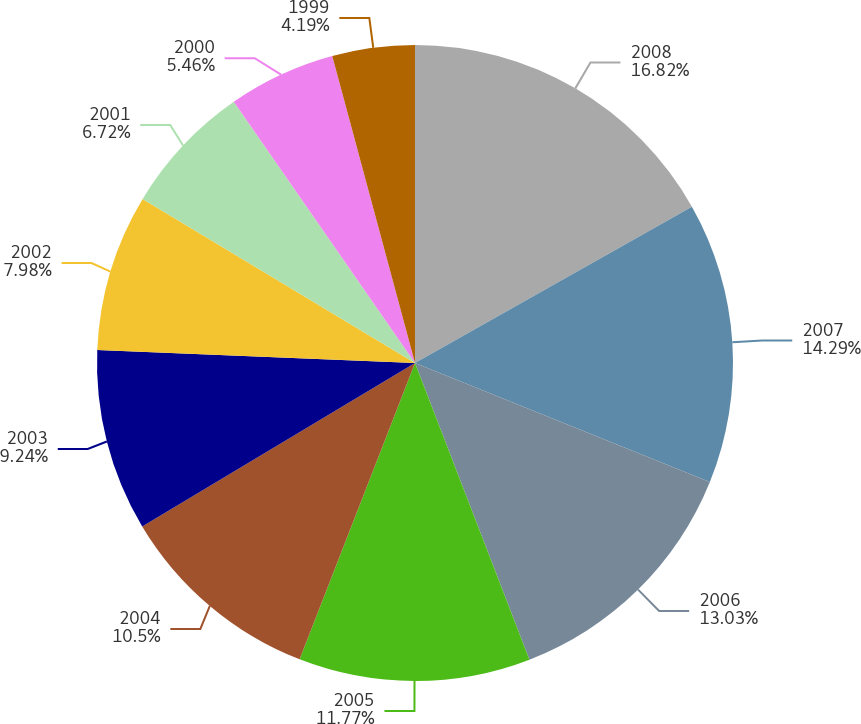<chart> <loc_0><loc_0><loc_500><loc_500><pie_chart><fcel>2008<fcel>2007<fcel>2006<fcel>2005<fcel>2004<fcel>2003<fcel>2002<fcel>2001<fcel>2000<fcel>1999<nl><fcel>16.82%<fcel>14.29%<fcel>13.03%<fcel>11.77%<fcel>10.5%<fcel>9.24%<fcel>7.98%<fcel>6.72%<fcel>5.46%<fcel>4.19%<nl></chart> 